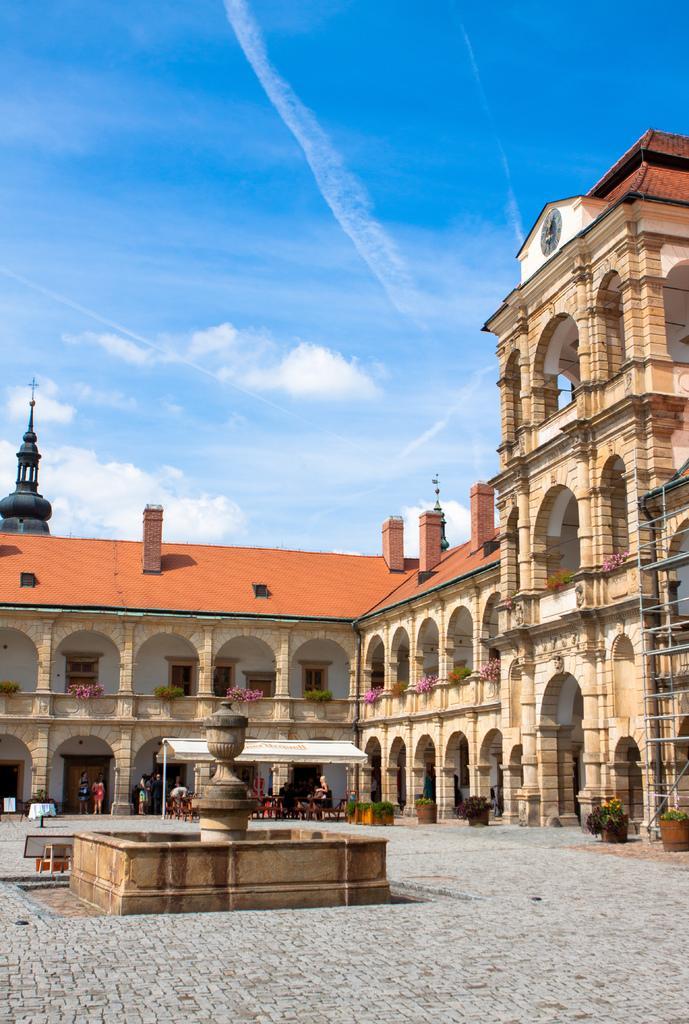In one or two sentences, can you explain what this image depicts? At the bottom of this image I can see the ground and also there is a fountain. In the background there is a building, in front of this building I can see few people are standing. On the top of the image I can see the sky and clouds. 